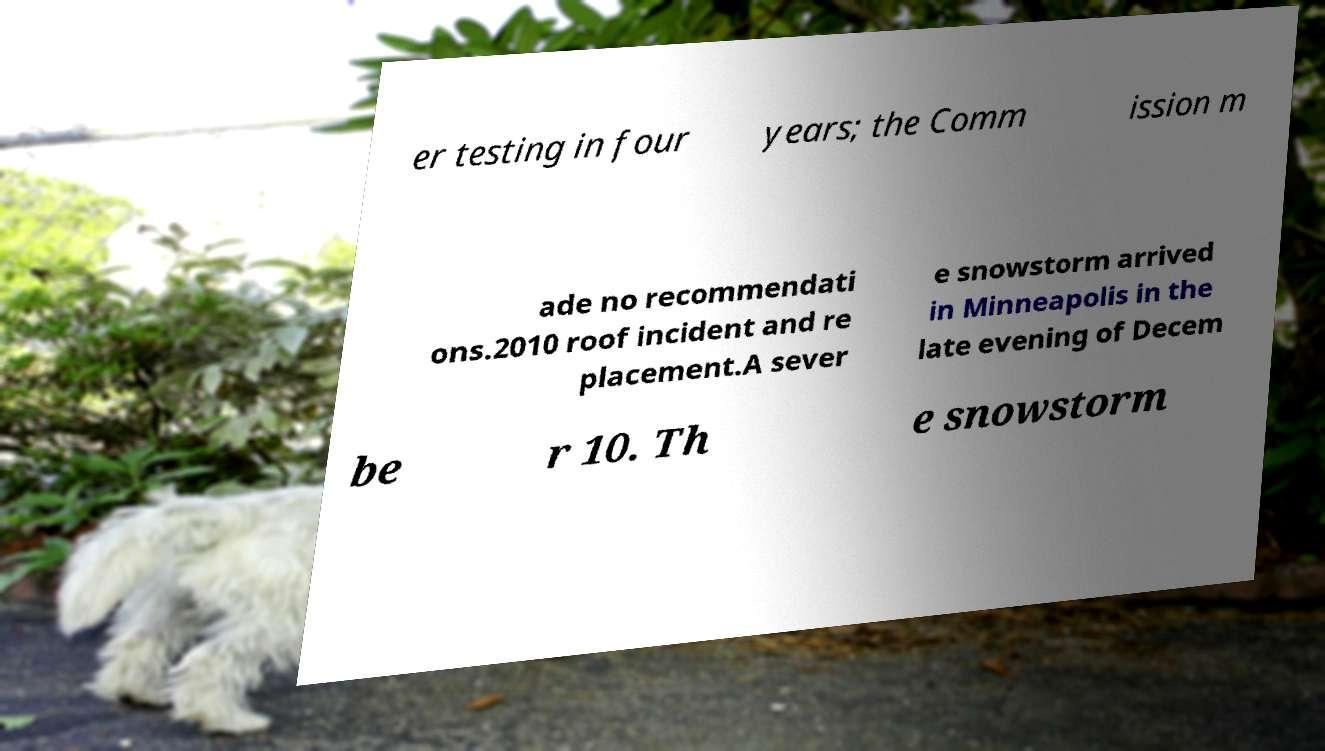Please identify and transcribe the text found in this image. er testing in four years; the Comm ission m ade no recommendati ons.2010 roof incident and re placement.A sever e snowstorm arrived in Minneapolis in the late evening of Decem be r 10. Th e snowstorm 